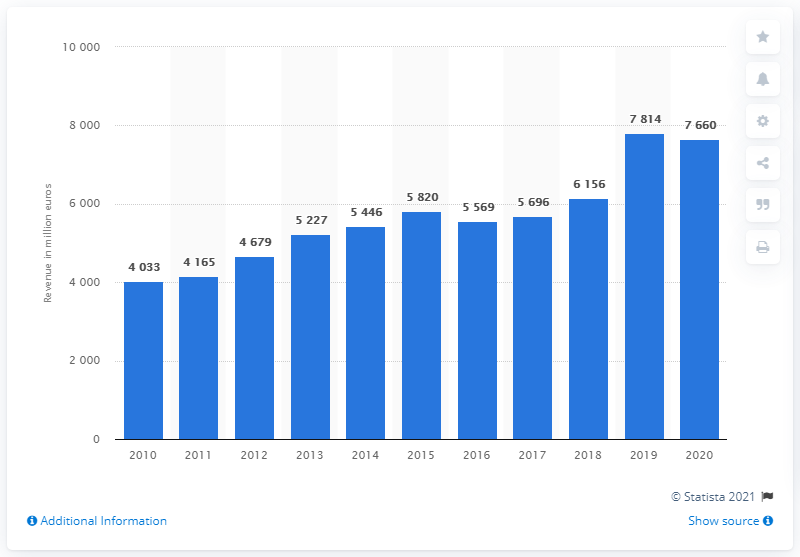Highlight a few significant elements in this photo. BASF reported revenue of 7660 million euros in the Agricultural Solutions segment in 2020. 